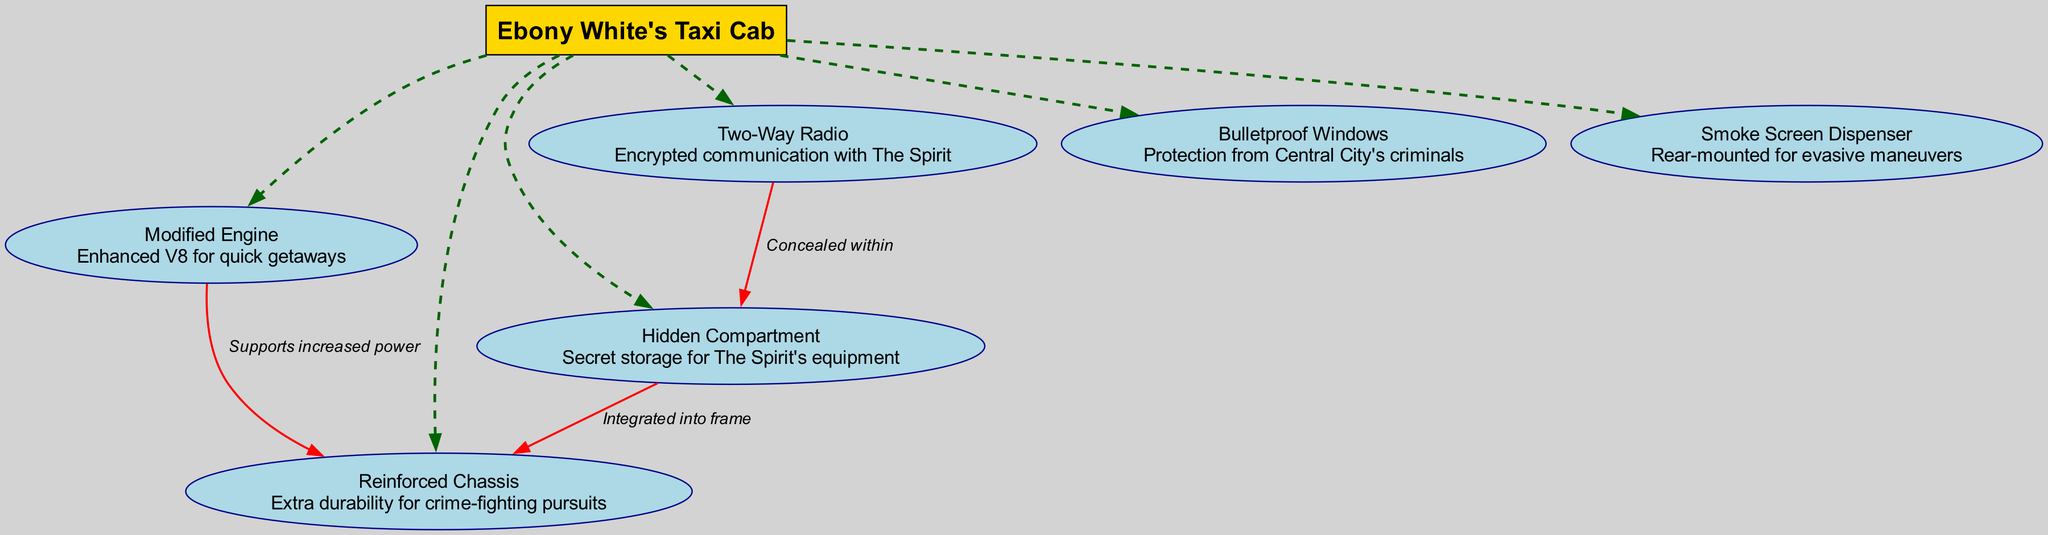What is the main component of the blueprint? The main component is clearly labeled at the top of the diagram, showing that it is "Ebony White's Taxi Cab."
Answer: Ebony White's Taxi Cab How many subcomponents are there in the design? Counting the subcomponents listed in the diagram, there are a total of six subcomponents detailed.
Answer: 6 What unique feature is integrated into the chassis? The connection labeled "Integrated into frame" indicates that the "Hidden Compartment" is specifically integrated with the "Reinforced Chassis."
Answer: Hidden Compartment What type of communication device is included in the taxi cab? The specific node labeled "Two-Way Radio" describes this feature as providing encrypted communication with The Spirit.
Answer: Two-Way Radio Which subcomponent supports increased power? The edge labeled "Supports increased power" relates the "Modified Engine" to the "Reinforced Chassis," indicating that it supports increased power.
Answer: Reinforced Chassis What modification provides protection from criminals? The node "Bulletproof Windows" indicates the modification that provides protection from Central City's criminals.
Answer: Bulletproof Windows How are the two-way radio and hidden compartment related? The edge labeled "Concealed within" connects "Two-Way Radio" to "Hidden Compartment," explaining that the radio is hidden in this compartment.
Answer: Concealed within Which component is designed for quick getaways? The "Modified Engine" is specifically designed and labeled as an enhanced V8 for quick getaways in the diagram.
Answer: Modified Engine What feature aids in evasive maneuvers? The connection labeled "Rear-mounted for evasive maneuvers" shows that the "Smoke Screen Dispenser" is the feature aiding in such maneuvers.
Answer: Smoke Screen Dispenser 